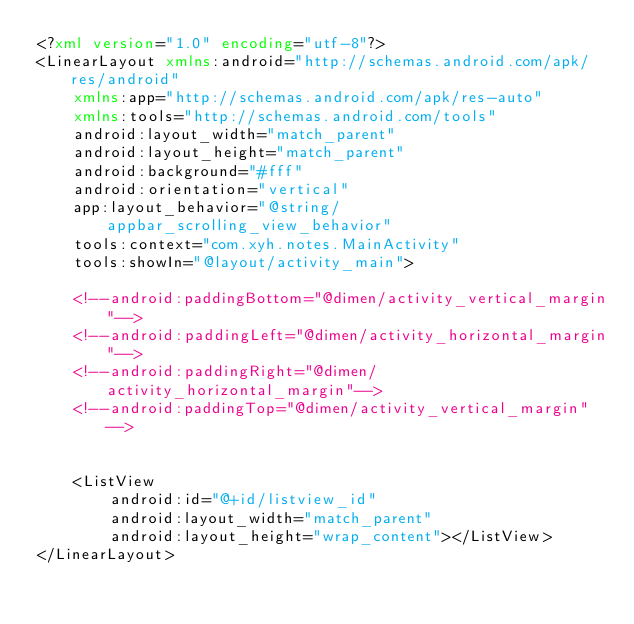Convert code to text. <code><loc_0><loc_0><loc_500><loc_500><_XML_><?xml version="1.0" encoding="utf-8"?>
<LinearLayout xmlns:android="http://schemas.android.com/apk/res/android"
    xmlns:app="http://schemas.android.com/apk/res-auto"
    xmlns:tools="http://schemas.android.com/tools"
    android:layout_width="match_parent"
    android:layout_height="match_parent"
    android:background="#fff"
    android:orientation="vertical"
    app:layout_behavior="@string/appbar_scrolling_view_behavior"
    tools:context="com.xyh.notes.MainActivity"
    tools:showIn="@layout/activity_main">

    <!--android:paddingBottom="@dimen/activity_vertical_margin"-->
    <!--android:paddingLeft="@dimen/activity_horizontal_margin"-->
    <!--android:paddingRight="@dimen/activity_horizontal_margin"-->
    <!--android:paddingTop="@dimen/activity_vertical_margin"-->


    <ListView
        android:id="@+id/listview_id"
        android:layout_width="match_parent"
        android:layout_height="wrap_content"></ListView>
</LinearLayout>
</code> 